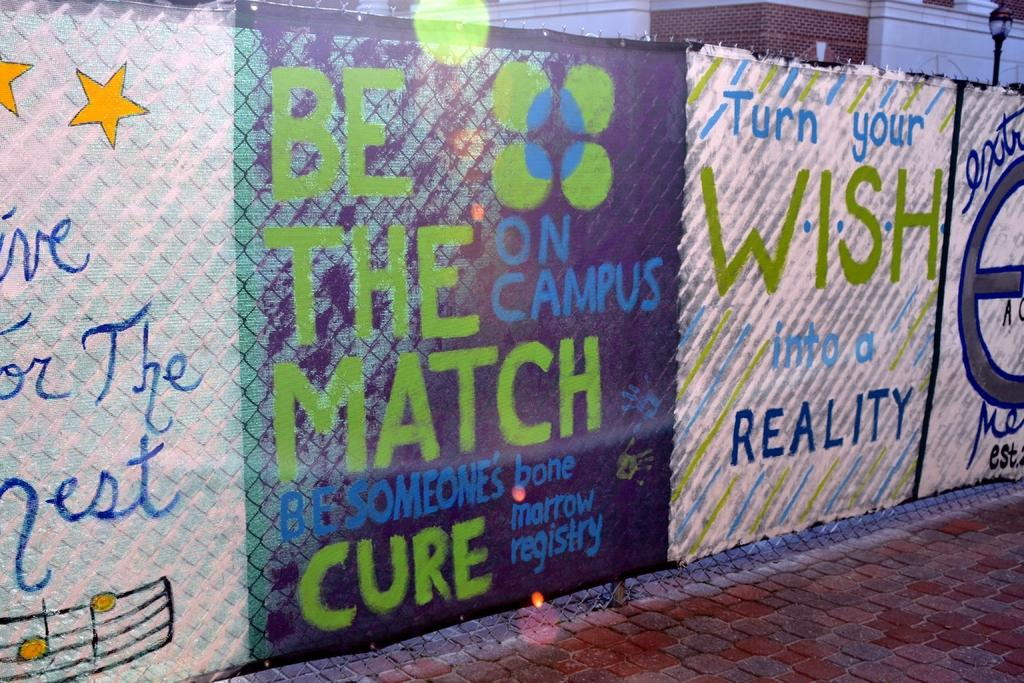<image>
Share a concise interpretation of the image provided. A painting that says Be The Match is draped over a fence. 